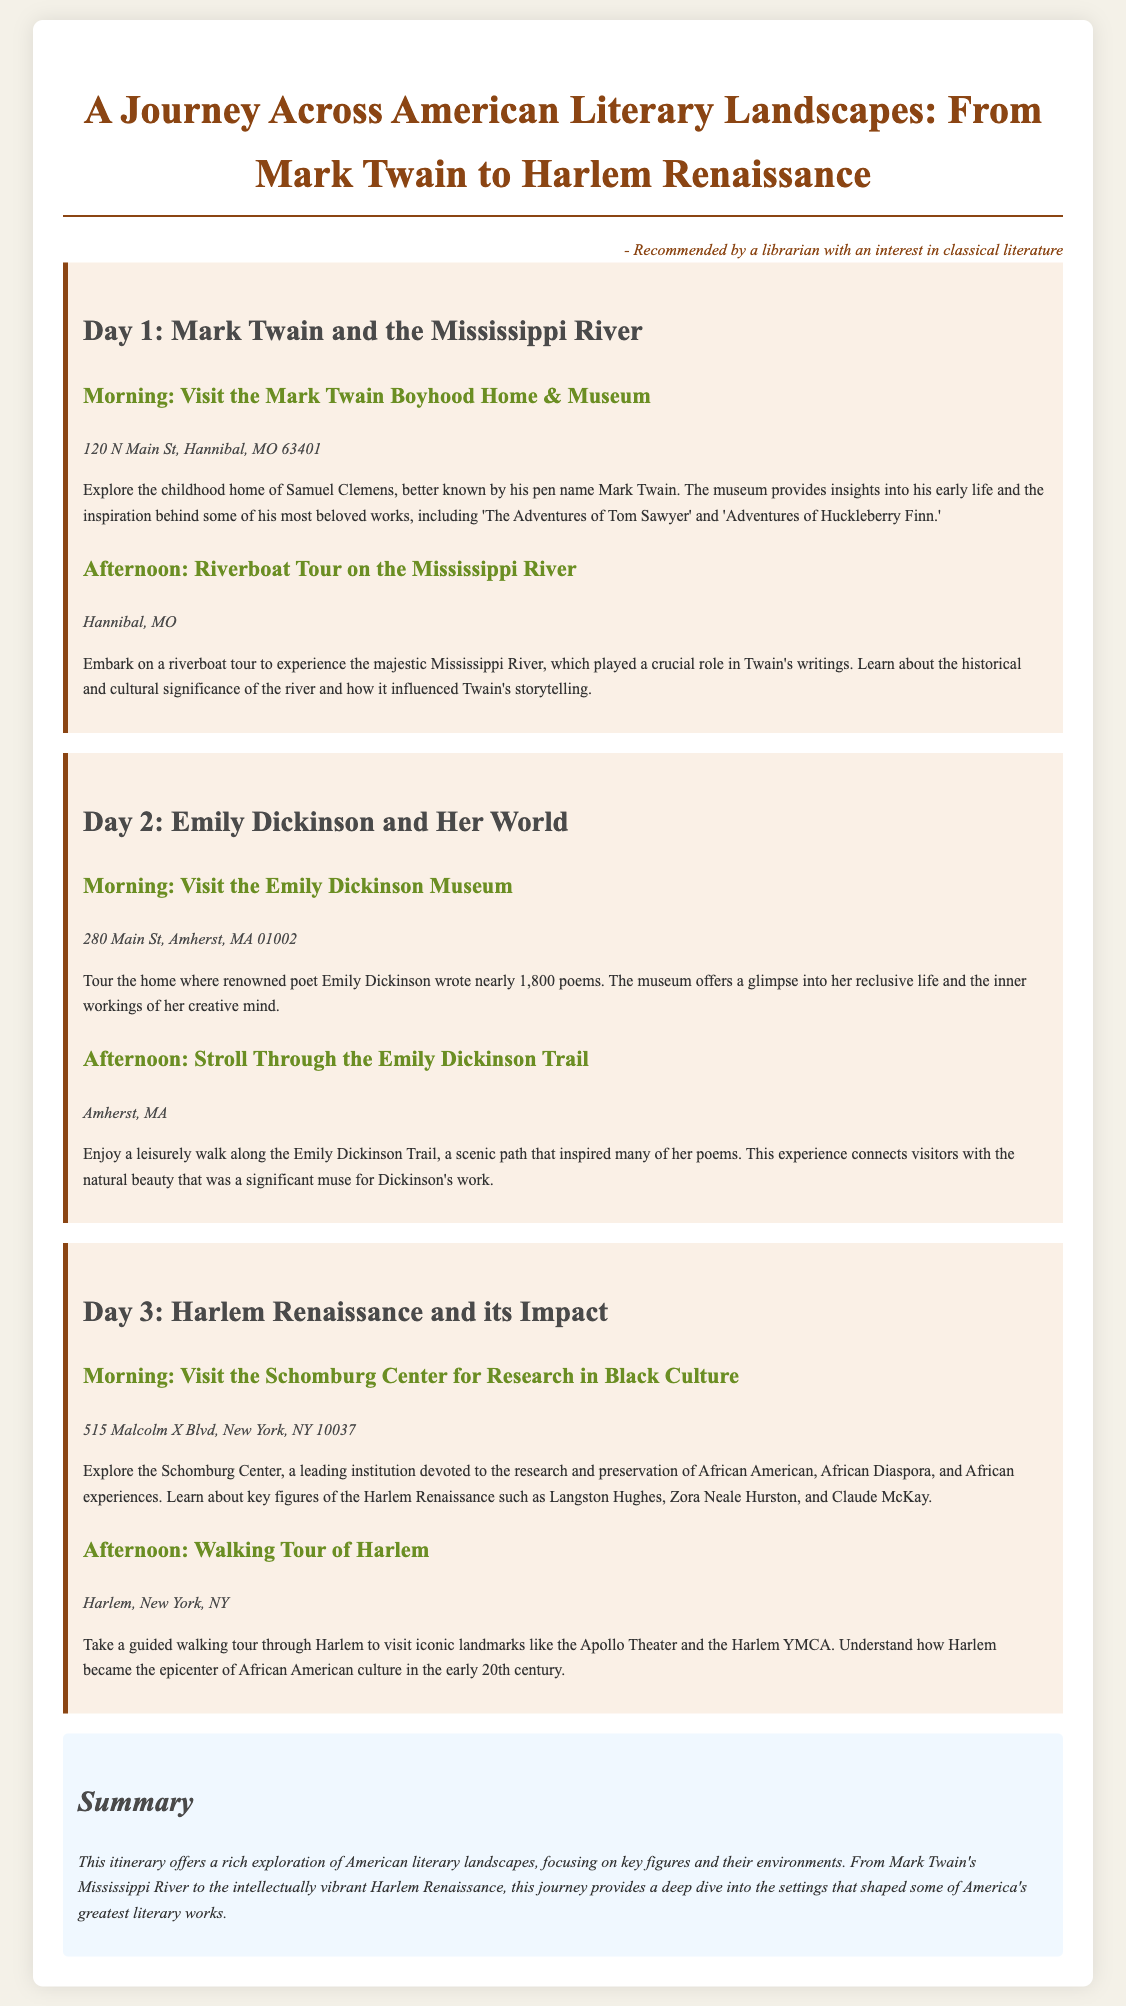What is the location of the Mark Twain Boyhood Home & Museum? The document provides the address for this location as "120 N Main St, Hannibal, MO 63401."
Answer: 120 N Main St, Hannibal, MO 63401 What is the theme of Day 3's itinerary? The focus of Day 3 is on the "Harlem Renaissance and its Impact," showcasing key cultural figures and landmarks.
Answer: Harlem Renaissance and its Impact Who wrote nearly 1,800 poems? The document mentions Emily Dickinson as the poet who wrote nearly 1,800 poems.
Answer: Emily Dickinson What is the purpose of the Schomburg Center for Research in Black Culture? The purpose of the center is devoted to research and preservation of African American experiences, as described in the itinerary.
Answer: Research and preservation of African American experiences Which activity is planned for the afternoon of Day 2? The afternoon activity for Day 2 is "Stroll Through the Emily Dickinson Trail."
Answer: Stroll Through the Emily Dickinson Trail How many days does the itinerary cover? The itinerary details activities across three different days.
Answer: Three days In which city is the Emily Dickinson Museum located? The document specifies that the Emily Dickinson Museum is located in Amherst, MA.
Answer: Amherst, MA What landmark is mentioned as part of the Harlem walking tour? The Apollo Theater is noted as an iconic landmark included in the Harlem walking tour.
Answer: Apollo Theater 